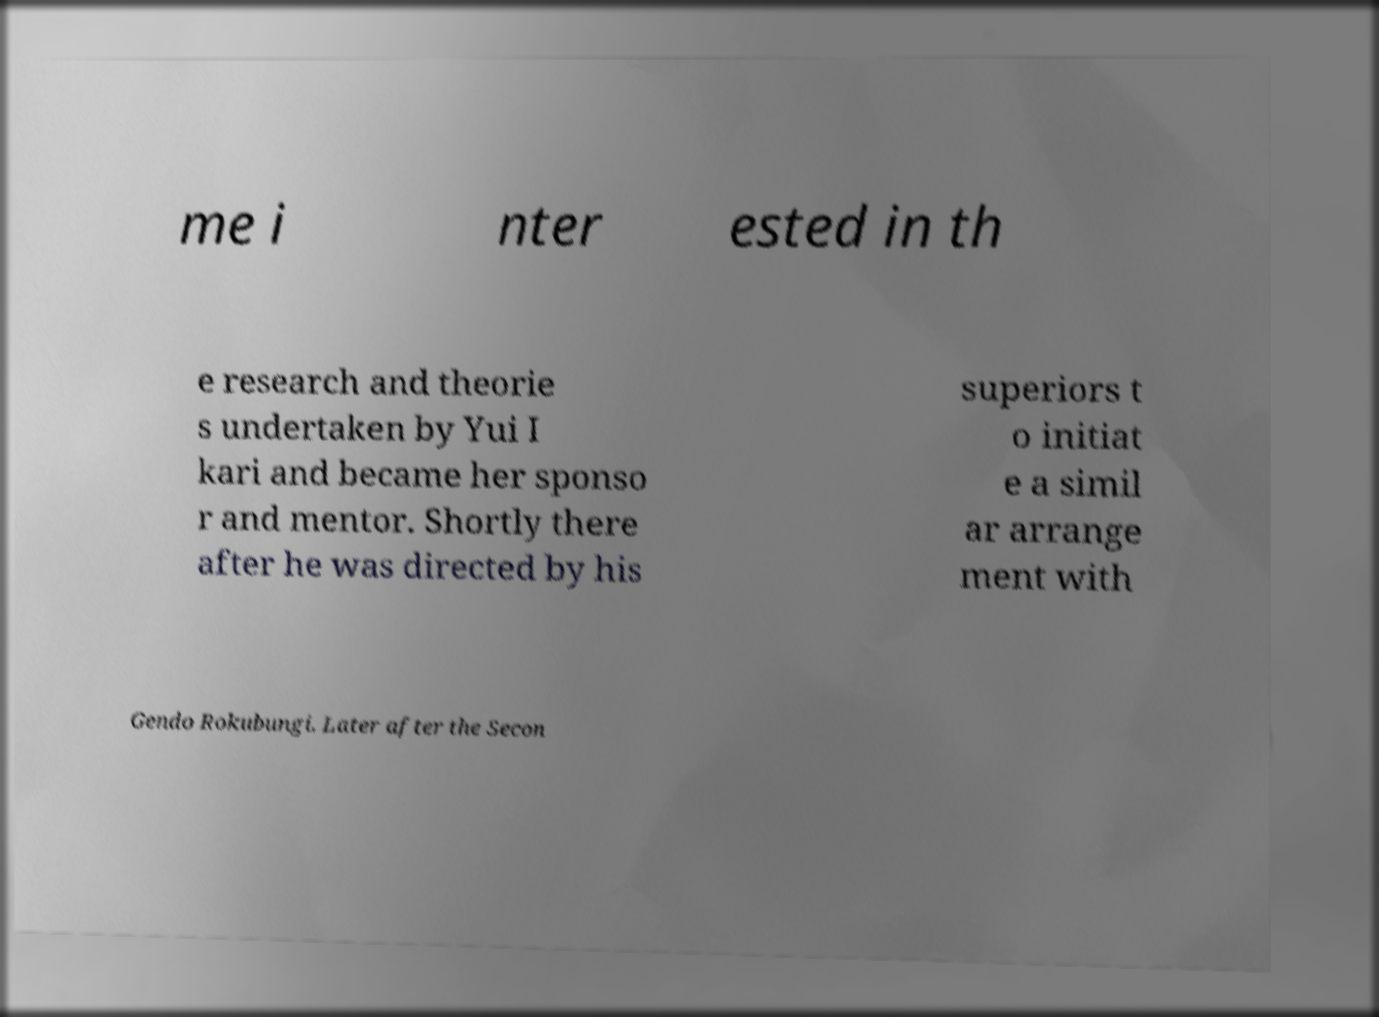Please identify and transcribe the text found in this image. me i nter ested in th e research and theorie s undertaken by Yui I kari and became her sponso r and mentor. Shortly there after he was directed by his superiors t o initiat e a simil ar arrange ment with Gendo Rokubungi. Later after the Secon 